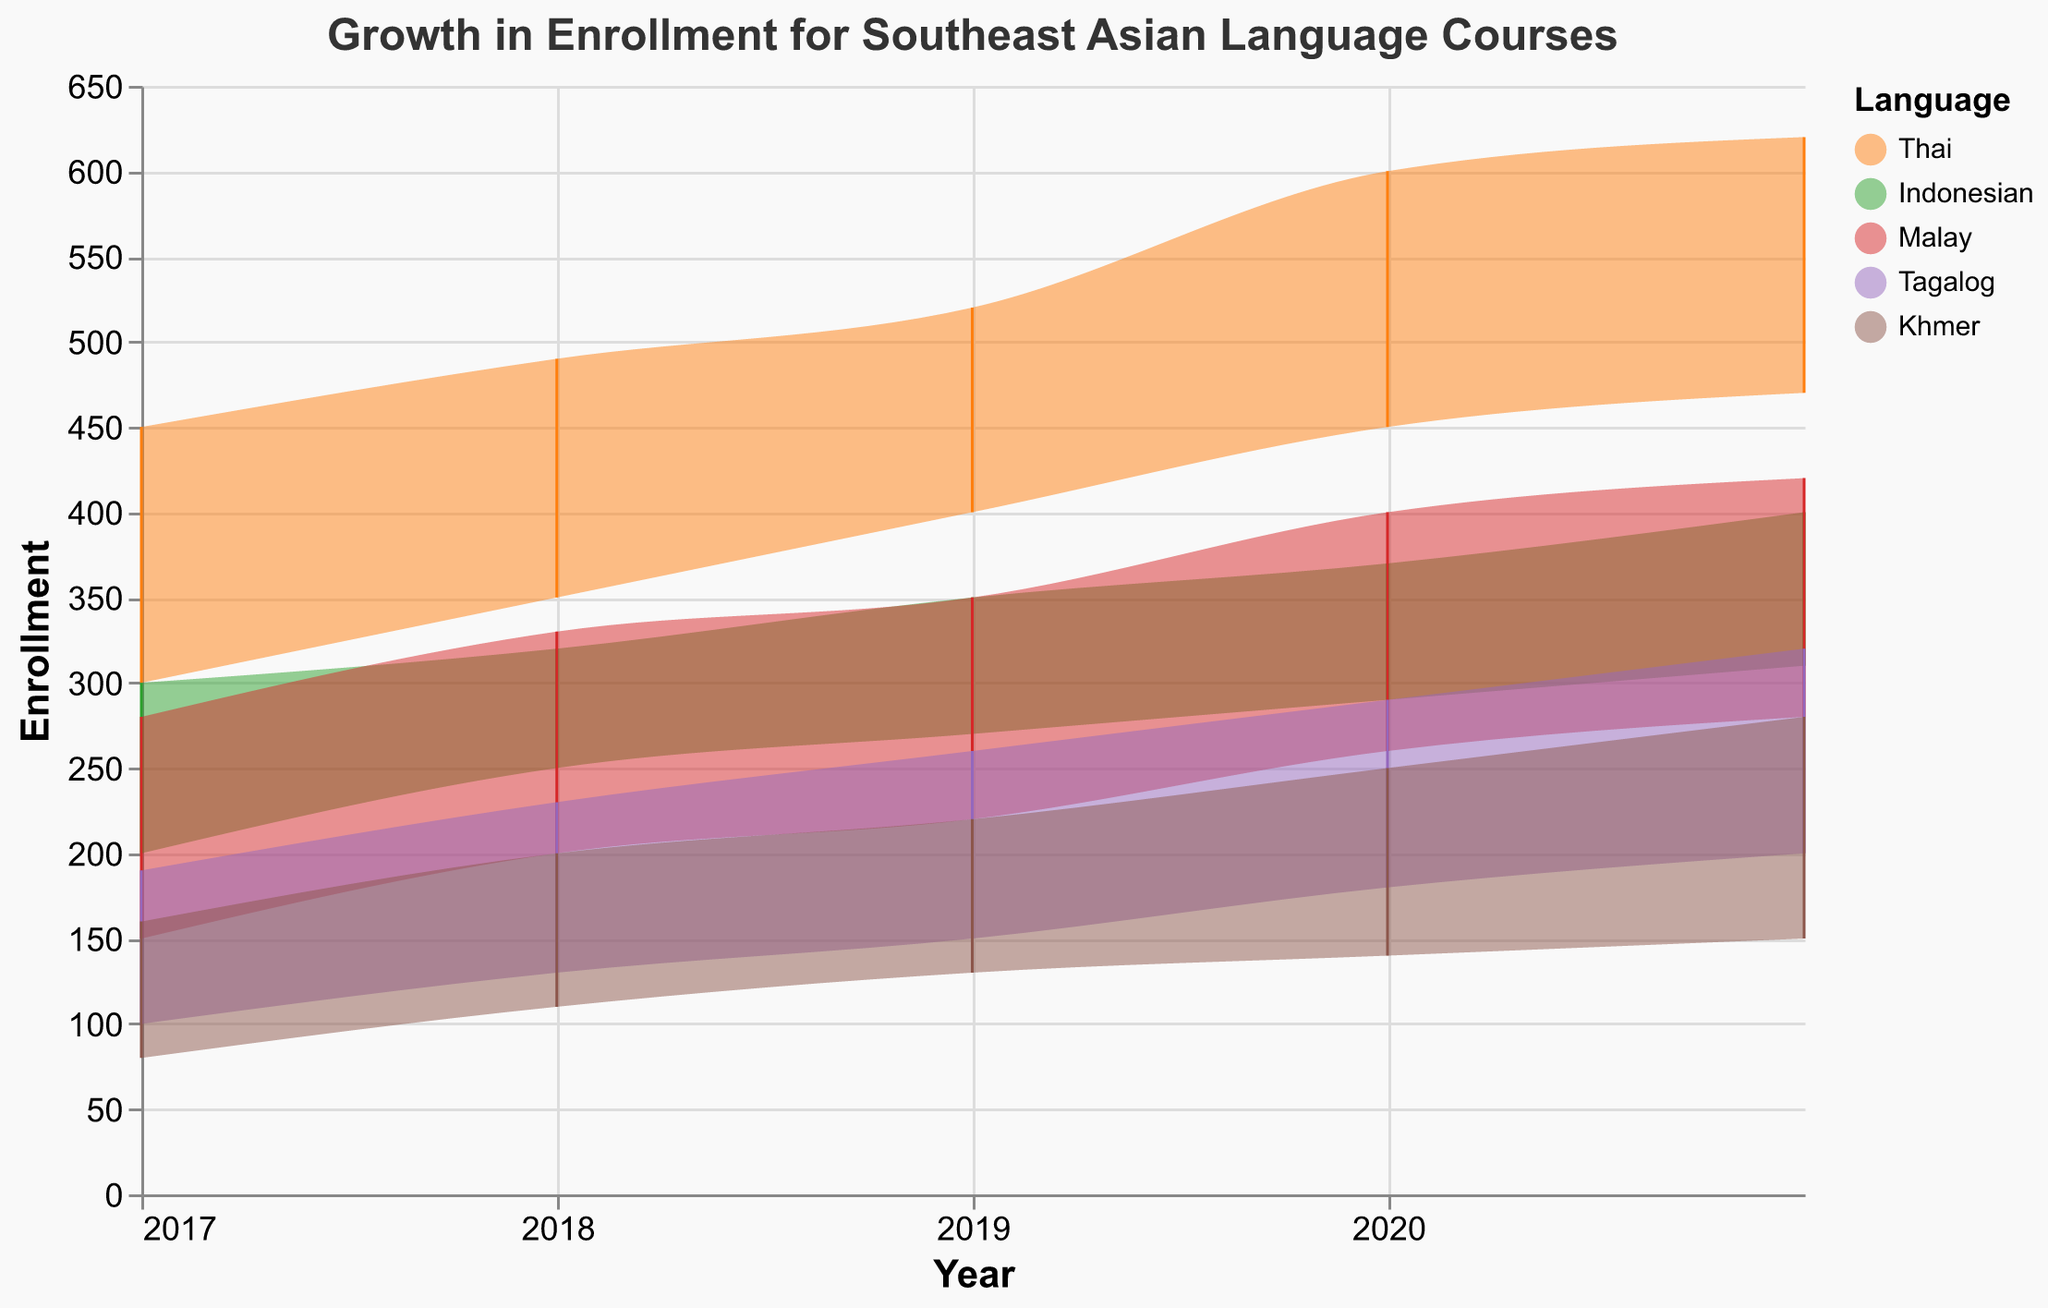What is the title of the figure? The title is located at the top of the figure, reading "Growth in Enrollment for Southeast Asian Language Courses". This provides a clear summary of what the chart represents.
Answer: Growth in Enrollment for Southeast Asian Language Courses Which language had the highest maximum enrollment in 2021? To find this, look at the top bound of the shaded areas for each language in the year 2021. The language with the highest top bound line is Thai.
Answer: Thai What was the range of enrollments for the Tagalog language course in 2019? For 2019, observe the lower and upper bounds of the shaded area for the Tagalog course. The minimum enrollment is 150 and the maximum enrollment is 260. The range is the difference between these two values.
Answer: 110 (260 - 150) Which language showed the greatest growth in minimum enrollment from 2017 to 2021? Compare the minimum enrollment values for each language between 2017 and 2021. The differences are Thai (470-300=170), Indonesian (310-200=110), Malay (280-150=130), Tagalog (200-100=100), and Khmer (150-80=70).
Answer: Thai Between which years did the Malay language course see the most significant increase in maximum enrollment? Examine the maximum enrollment values for Malay from year to year. The increases are: 2017-2018 (330-280=50), 2018-2019 (350-330=20), 2019-2020 (400-350=50), 2020-2021 (420-400=20). The largest increase is between 2017-2018 and 2019-2020, both 50.
Answer: 2017-2018 and 2019-2020 Which language had the smallest range of enrollment throughout the years? For each language, look at the maximum range (difference between maximum and minimum enrollments) by examining the height of the shaded areas. Khmer consistently has the smallest range.
Answer: Khmer What is the trend of the Thai language course enrollment over the years? Looking at both shaded areas and the lines for Thai over the years, you can see an overall upward trend in both minimum and maximum enrollments from 2017 to 2021.
Answer: Increasing How does the enrollment trend of Khmer compare to Indonesian? Examine the shaded areas and lines for Khmer and Indonesian from 2017 to 2021. Both show an upward trend, but the Cambodian language's enrollment range increases more gradually compared to Indonesian.
Answer: Khmer has a more gradual increase compared to Indonesian What year did the Tagalog language course enrollment show a notable increase? Look for significant rises in the lines or shaded areas for Tagalog. The sharpest increase is between 2017 and 2018.
Answer: 2018 Which language had the most significant increase in maximum enrollment in 2021 compared to 2020? Compare maximum enrollments for each language from 2020 to 2021: Thai (620-600=20), Indonesian (400-370=30), Malay (420-400=20), Tagalog (320-290=30), Khmer (280-250=30). The increases are tied between Indonesian, Tagalog, and Khmer.
Answer: Indonesian, Tagalog, and Khmer 